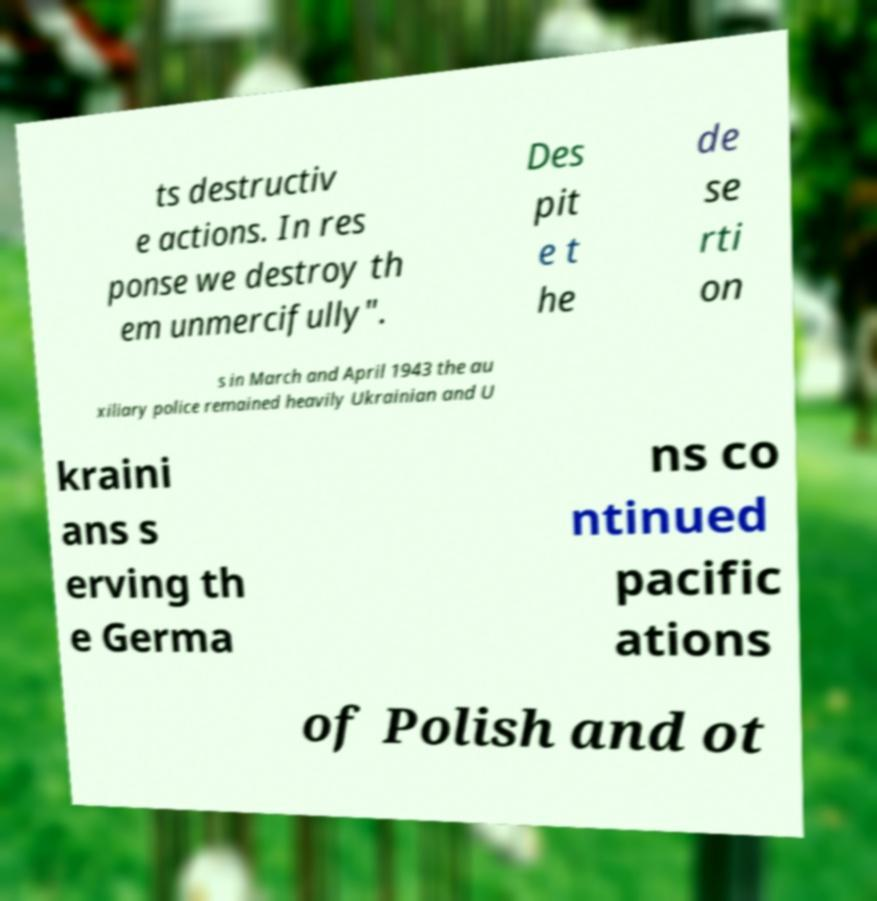I need the written content from this picture converted into text. Can you do that? ts destructiv e actions. In res ponse we destroy th em unmercifully". Des pit e t he de se rti on s in March and April 1943 the au xiliary police remained heavily Ukrainian and U kraini ans s erving th e Germa ns co ntinued pacific ations of Polish and ot 